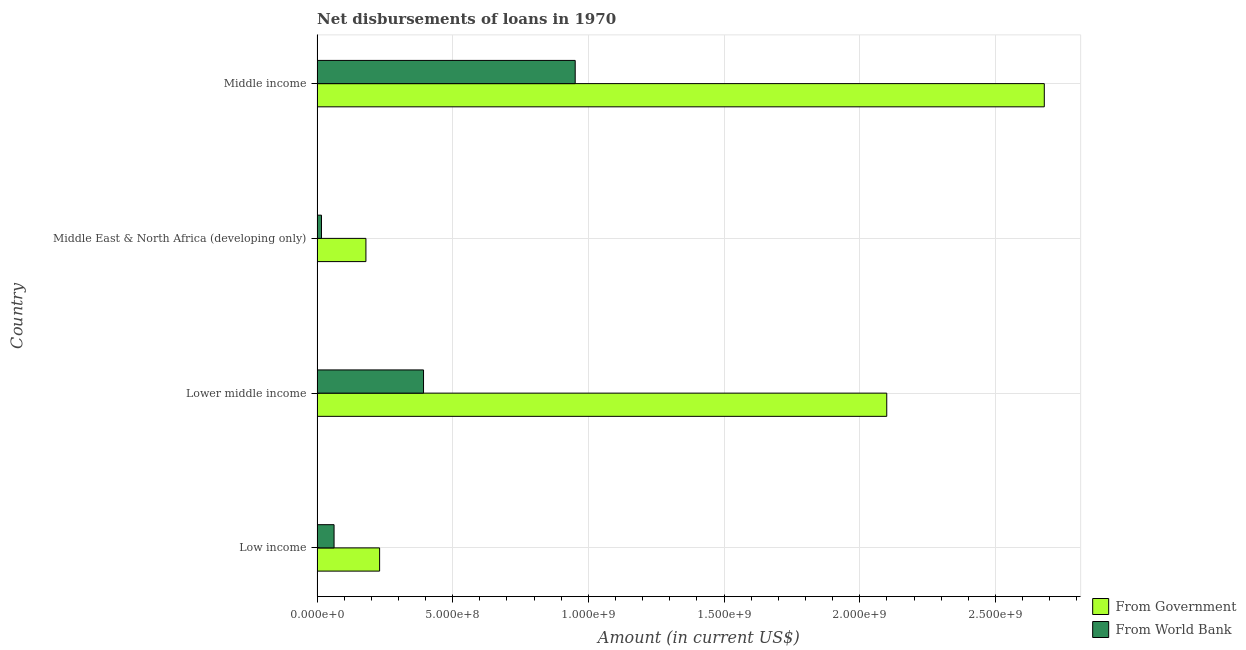How many different coloured bars are there?
Provide a short and direct response. 2. Are the number of bars per tick equal to the number of legend labels?
Ensure brevity in your answer.  Yes. Are the number of bars on each tick of the Y-axis equal?
Offer a terse response. Yes. How many bars are there on the 1st tick from the bottom?
Your response must be concise. 2. What is the label of the 3rd group of bars from the top?
Your answer should be very brief. Lower middle income. In how many cases, is the number of bars for a given country not equal to the number of legend labels?
Your answer should be very brief. 0. What is the net disbursements of loan from government in Lower middle income?
Make the answer very short. 2.10e+09. Across all countries, what is the maximum net disbursements of loan from government?
Provide a short and direct response. 2.68e+09. Across all countries, what is the minimum net disbursements of loan from world bank?
Your response must be concise. 1.64e+07. In which country was the net disbursements of loan from world bank minimum?
Provide a succinct answer. Middle East & North Africa (developing only). What is the total net disbursements of loan from world bank in the graph?
Provide a succinct answer. 1.42e+09. What is the difference between the net disbursements of loan from government in Low income and that in Lower middle income?
Your response must be concise. -1.87e+09. What is the difference between the net disbursements of loan from government in Middle income and the net disbursements of loan from world bank in Low income?
Offer a very short reply. 2.62e+09. What is the average net disbursements of loan from world bank per country?
Ensure brevity in your answer.  3.56e+08. What is the difference between the net disbursements of loan from government and net disbursements of loan from world bank in Middle East & North Africa (developing only)?
Your answer should be compact. 1.64e+08. What is the ratio of the net disbursements of loan from world bank in Low income to that in Lower middle income?
Your response must be concise. 0.16. Is the difference between the net disbursements of loan from government in Lower middle income and Middle East & North Africa (developing only) greater than the difference between the net disbursements of loan from world bank in Lower middle income and Middle East & North Africa (developing only)?
Provide a succinct answer. Yes. What is the difference between the highest and the second highest net disbursements of loan from world bank?
Your answer should be very brief. 5.59e+08. What is the difference between the highest and the lowest net disbursements of loan from government?
Your answer should be very brief. 2.50e+09. What does the 1st bar from the top in Middle income represents?
Make the answer very short. From World Bank. What does the 2nd bar from the bottom in Lower middle income represents?
Offer a very short reply. From World Bank. Are all the bars in the graph horizontal?
Provide a succinct answer. Yes. What is the difference between two consecutive major ticks on the X-axis?
Keep it short and to the point. 5.00e+08. What is the title of the graph?
Keep it short and to the point. Net disbursements of loans in 1970. Does "By country of origin" appear as one of the legend labels in the graph?
Give a very brief answer. No. What is the label or title of the Y-axis?
Offer a very short reply. Country. What is the Amount (in current US$) of From Government in Low income?
Your answer should be very brief. 2.31e+08. What is the Amount (in current US$) in From World Bank in Low income?
Give a very brief answer. 6.27e+07. What is the Amount (in current US$) of From Government in Lower middle income?
Provide a short and direct response. 2.10e+09. What is the Amount (in current US$) of From World Bank in Lower middle income?
Provide a short and direct response. 3.92e+08. What is the Amount (in current US$) of From Government in Middle East & North Africa (developing only)?
Provide a short and direct response. 1.80e+08. What is the Amount (in current US$) of From World Bank in Middle East & North Africa (developing only)?
Provide a succinct answer. 1.64e+07. What is the Amount (in current US$) in From Government in Middle income?
Keep it short and to the point. 2.68e+09. What is the Amount (in current US$) of From World Bank in Middle income?
Make the answer very short. 9.51e+08. Across all countries, what is the maximum Amount (in current US$) in From Government?
Ensure brevity in your answer.  2.68e+09. Across all countries, what is the maximum Amount (in current US$) of From World Bank?
Your response must be concise. 9.51e+08. Across all countries, what is the minimum Amount (in current US$) of From Government?
Your answer should be very brief. 1.80e+08. Across all countries, what is the minimum Amount (in current US$) of From World Bank?
Give a very brief answer. 1.64e+07. What is the total Amount (in current US$) of From Government in the graph?
Provide a short and direct response. 5.19e+09. What is the total Amount (in current US$) of From World Bank in the graph?
Ensure brevity in your answer.  1.42e+09. What is the difference between the Amount (in current US$) in From Government in Low income and that in Lower middle income?
Offer a terse response. -1.87e+09. What is the difference between the Amount (in current US$) in From World Bank in Low income and that in Lower middle income?
Offer a terse response. -3.30e+08. What is the difference between the Amount (in current US$) of From Government in Low income and that in Middle East & North Africa (developing only)?
Provide a succinct answer. 5.04e+07. What is the difference between the Amount (in current US$) in From World Bank in Low income and that in Middle East & North Africa (developing only)?
Make the answer very short. 4.63e+07. What is the difference between the Amount (in current US$) in From Government in Low income and that in Middle income?
Provide a short and direct response. -2.45e+09. What is the difference between the Amount (in current US$) in From World Bank in Low income and that in Middle income?
Provide a short and direct response. -8.89e+08. What is the difference between the Amount (in current US$) of From Government in Lower middle income and that in Middle East & North Africa (developing only)?
Provide a succinct answer. 1.92e+09. What is the difference between the Amount (in current US$) in From World Bank in Lower middle income and that in Middle East & North Africa (developing only)?
Your answer should be very brief. 3.76e+08. What is the difference between the Amount (in current US$) in From Government in Lower middle income and that in Middle income?
Keep it short and to the point. -5.81e+08. What is the difference between the Amount (in current US$) of From World Bank in Lower middle income and that in Middle income?
Provide a succinct answer. -5.59e+08. What is the difference between the Amount (in current US$) of From Government in Middle East & North Africa (developing only) and that in Middle income?
Ensure brevity in your answer.  -2.50e+09. What is the difference between the Amount (in current US$) of From World Bank in Middle East & North Africa (developing only) and that in Middle income?
Your answer should be very brief. -9.35e+08. What is the difference between the Amount (in current US$) in From Government in Low income and the Amount (in current US$) in From World Bank in Lower middle income?
Keep it short and to the point. -1.62e+08. What is the difference between the Amount (in current US$) of From Government in Low income and the Amount (in current US$) of From World Bank in Middle East & North Africa (developing only)?
Your answer should be very brief. 2.14e+08. What is the difference between the Amount (in current US$) in From Government in Low income and the Amount (in current US$) in From World Bank in Middle income?
Make the answer very short. -7.21e+08. What is the difference between the Amount (in current US$) in From Government in Lower middle income and the Amount (in current US$) in From World Bank in Middle East & North Africa (developing only)?
Offer a very short reply. 2.08e+09. What is the difference between the Amount (in current US$) in From Government in Lower middle income and the Amount (in current US$) in From World Bank in Middle income?
Your response must be concise. 1.15e+09. What is the difference between the Amount (in current US$) in From Government in Middle East & North Africa (developing only) and the Amount (in current US$) in From World Bank in Middle income?
Provide a short and direct response. -7.71e+08. What is the average Amount (in current US$) in From Government per country?
Your answer should be compact. 1.30e+09. What is the average Amount (in current US$) of From World Bank per country?
Give a very brief answer. 3.56e+08. What is the difference between the Amount (in current US$) of From Government and Amount (in current US$) of From World Bank in Low income?
Keep it short and to the point. 1.68e+08. What is the difference between the Amount (in current US$) of From Government and Amount (in current US$) of From World Bank in Lower middle income?
Give a very brief answer. 1.71e+09. What is the difference between the Amount (in current US$) of From Government and Amount (in current US$) of From World Bank in Middle East & North Africa (developing only)?
Ensure brevity in your answer.  1.64e+08. What is the difference between the Amount (in current US$) in From Government and Amount (in current US$) in From World Bank in Middle income?
Your response must be concise. 1.73e+09. What is the ratio of the Amount (in current US$) in From Government in Low income to that in Lower middle income?
Give a very brief answer. 0.11. What is the ratio of the Amount (in current US$) of From World Bank in Low income to that in Lower middle income?
Make the answer very short. 0.16. What is the ratio of the Amount (in current US$) in From Government in Low income to that in Middle East & North Africa (developing only)?
Provide a succinct answer. 1.28. What is the ratio of the Amount (in current US$) in From World Bank in Low income to that in Middle East & North Africa (developing only)?
Your answer should be very brief. 3.83. What is the ratio of the Amount (in current US$) in From Government in Low income to that in Middle income?
Your answer should be compact. 0.09. What is the ratio of the Amount (in current US$) in From World Bank in Low income to that in Middle income?
Make the answer very short. 0.07. What is the ratio of the Amount (in current US$) in From Government in Lower middle income to that in Middle East & North Africa (developing only)?
Your answer should be very brief. 11.66. What is the ratio of the Amount (in current US$) in From World Bank in Lower middle income to that in Middle East & North Africa (developing only)?
Offer a very short reply. 23.99. What is the ratio of the Amount (in current US$) of From Government in Lower middle income to that in Middle income?
Your answer should be compact. 0.78. What is the ratio of the Amount (in current US$) in From World Bank in Lower middle income to that in Middle income?
Offer a terse response. 0.41. What is the ratio of the Amount (in current US$) of From Government in Middle East & North Africa (developing only) to that in Middle income?
Your response must be concise. 0.07. What is the ratio of the Amount (in current US$) of From World Bank in Middle East & North Africa (developing only) to that in Middle income?
Offer a very short reply. 0.02. What is the difference between the highest and the second highest Amount (in current US$) in From Government?
Make the answer very short. 5.81e+08. What is the difference between the highest and the second highest Amount (in current US$) in From World Bank?
Your response must be concise. 5.59e+08. What is the difference between the highest and the lowest Amount (in current US$) in From Government?
Your answer should be compact. 2.50e+09. What is the difference between the highest and the lowest Amount (in current US$) of From World Bank?
Ensure brevity in your answer.  9.35e+08. 